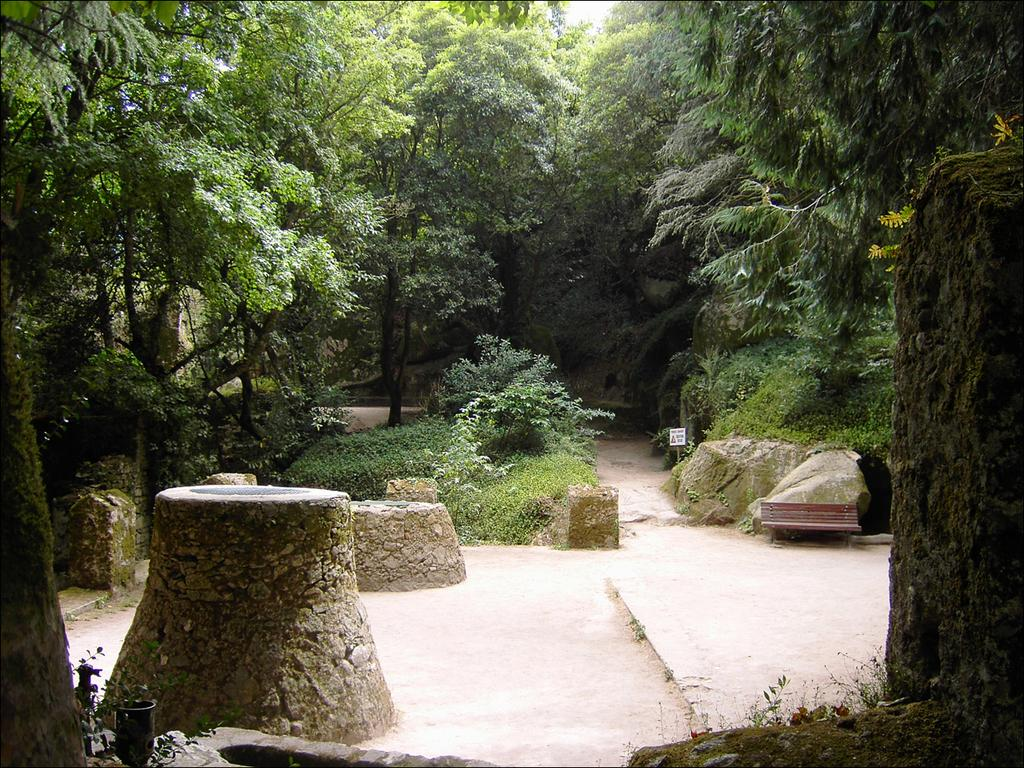What can be seen in the middle of the image? There are trees, stones, a bench, a poster, plants, and grass in the middle of the image. What type of vegetation is present in the image? There are trees, plants, and grass in the image. What is the background of the image? The sky is visible in the image. How many beads are scattered on the grass in the image? There are no beads present in the image; it features trees, stones, a bench, a poster, plants, and grass. What type of property is shown in the image? The image does not depict any specific property; it focuses on the objects and vegetation in the middle of the image. 